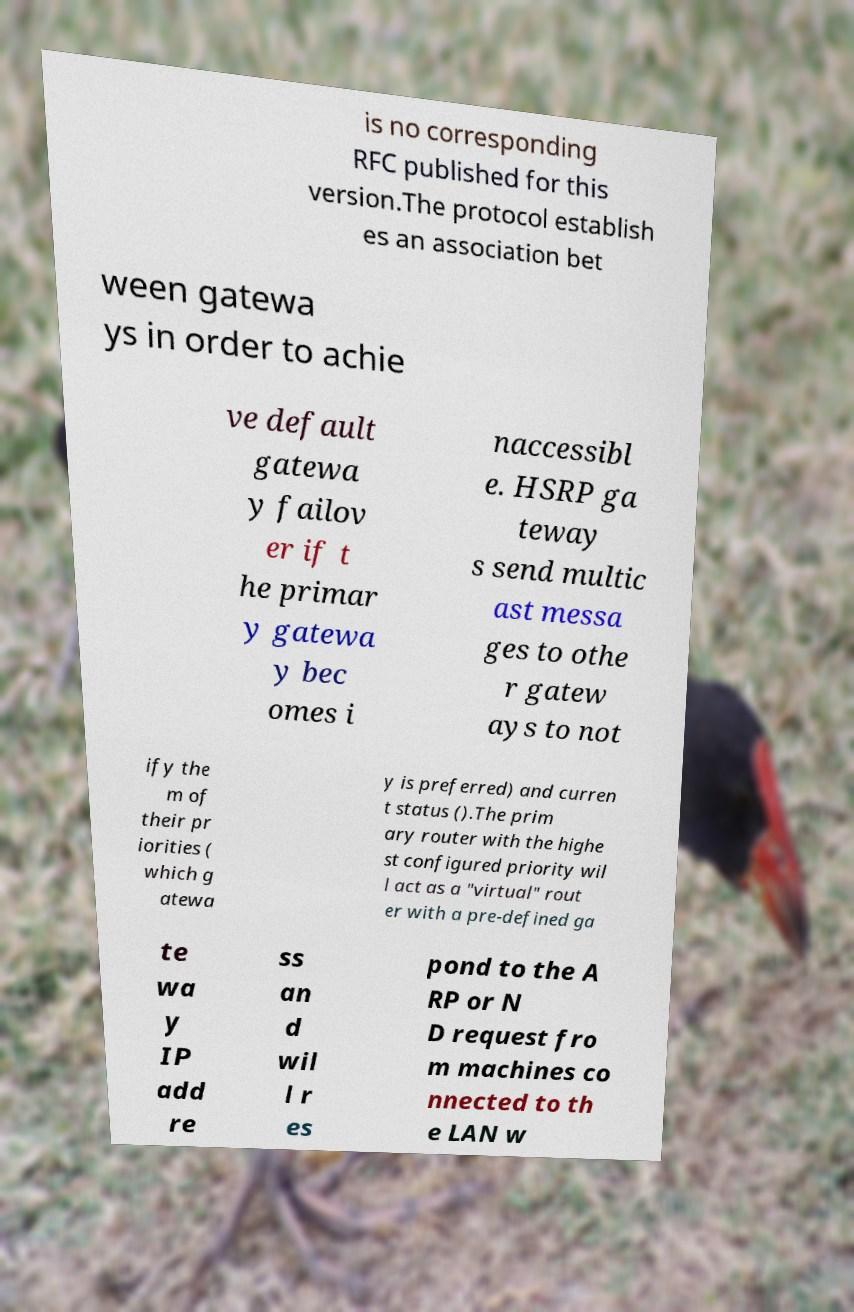For documentation purposes, I need the text within this image transcribed. Could you provide that? is no corresponding RFC published for this version.The protocol establish es an association bet ween gatewa ys in order to achie ve default gatewa y failov er if t he primar y gatewa y bec omes i naccessibl e. HSRP ga teway s send multic ast messa ges to othe r gatew ays to not ify the m of their pr iorities ( which g atewa y is preferred) and curren t status ().The prim ary router with the highe st configured priority wil l act as a "virtual" rout er with a pre-defined ga te wa y IP add re ss an d wil l r es pond to the A RP or N D request fro m machines co nnected to th e LAN w 